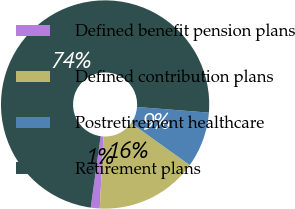Convert chart. <chart><loc_0><loc_0><loc_500><loc_500><pie_chart><fcel>Defined benefit pension plans<fcel>Defined contribution plans<fcel>Postretirement healthcare<fcel>Retirement plans<nl><fcel>1.39%<fcel>15.92%<fcel>8.65%<fcel>74.04%<nl></chart> 